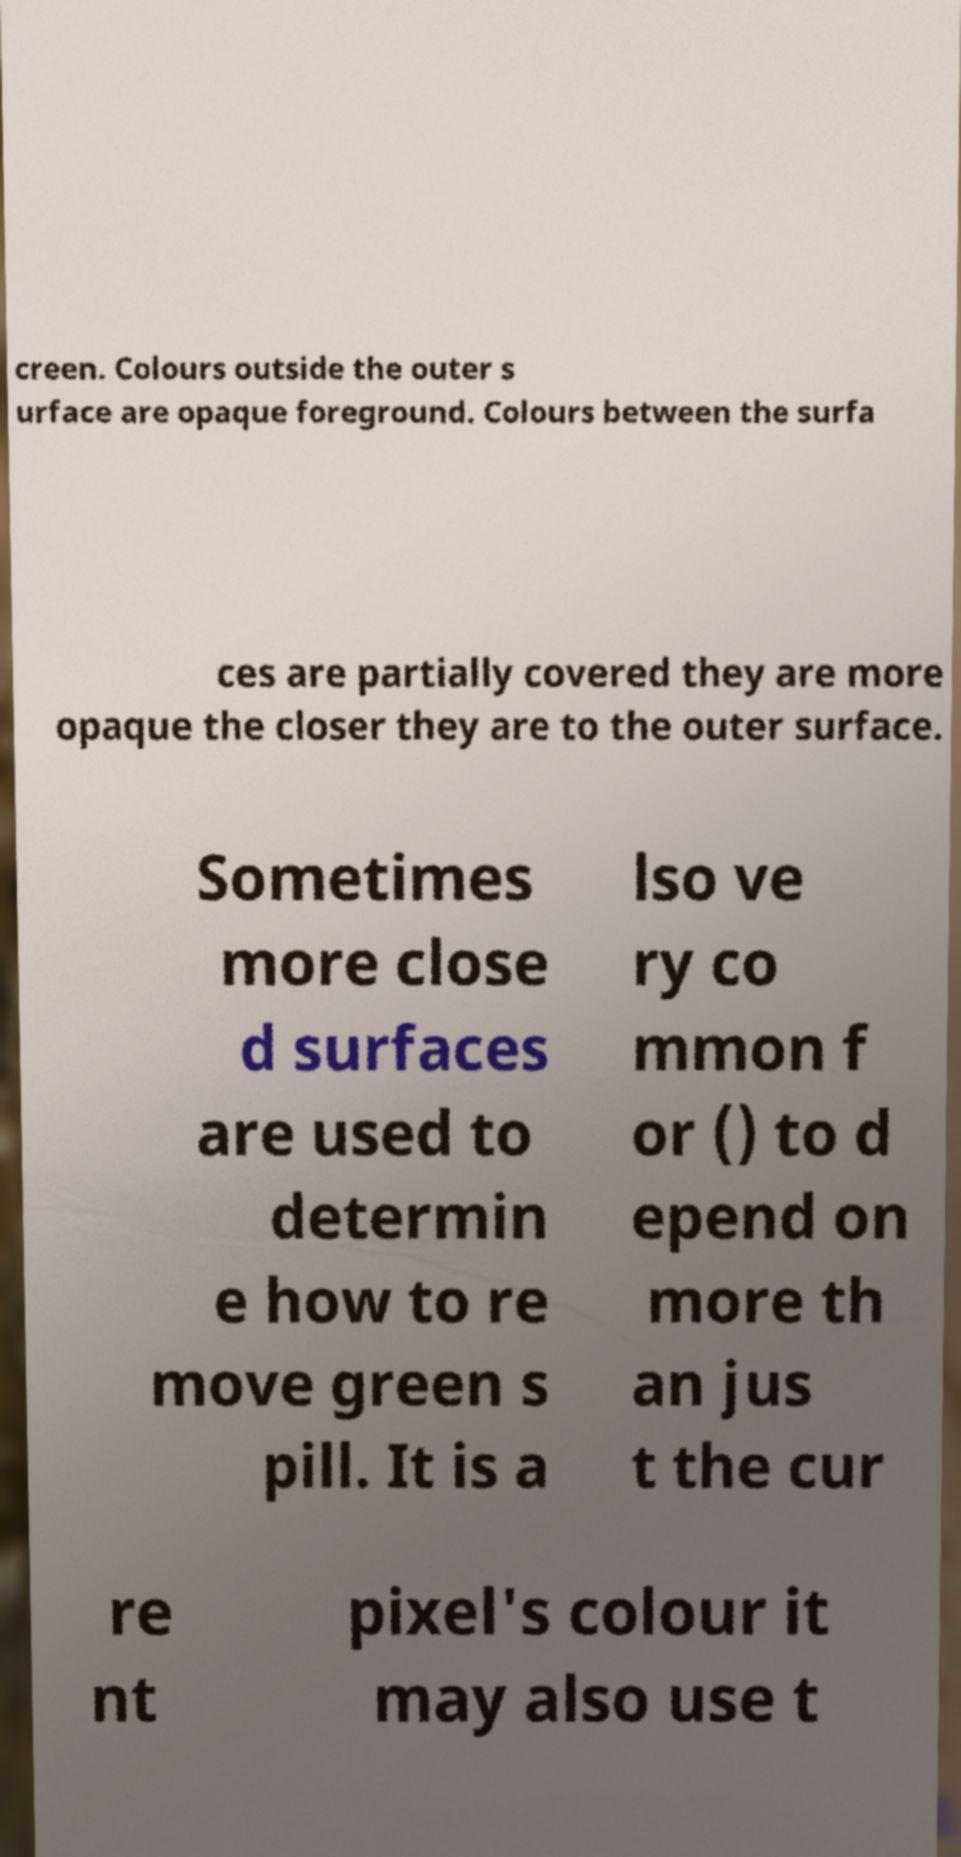Could you extract and type out the text from this image? creen. Colours outside the outer s urface are opaque foreground. Colours between the surfa ces are partially covered they are more opaque the closer they are to the outer surface. Sometimes more close d surfaces are used to determin e how to re move green s pill. It is a lso ve ry co mmon f or () to d epend on more th an jus t the cur re nt pixel's colour it may also use t 